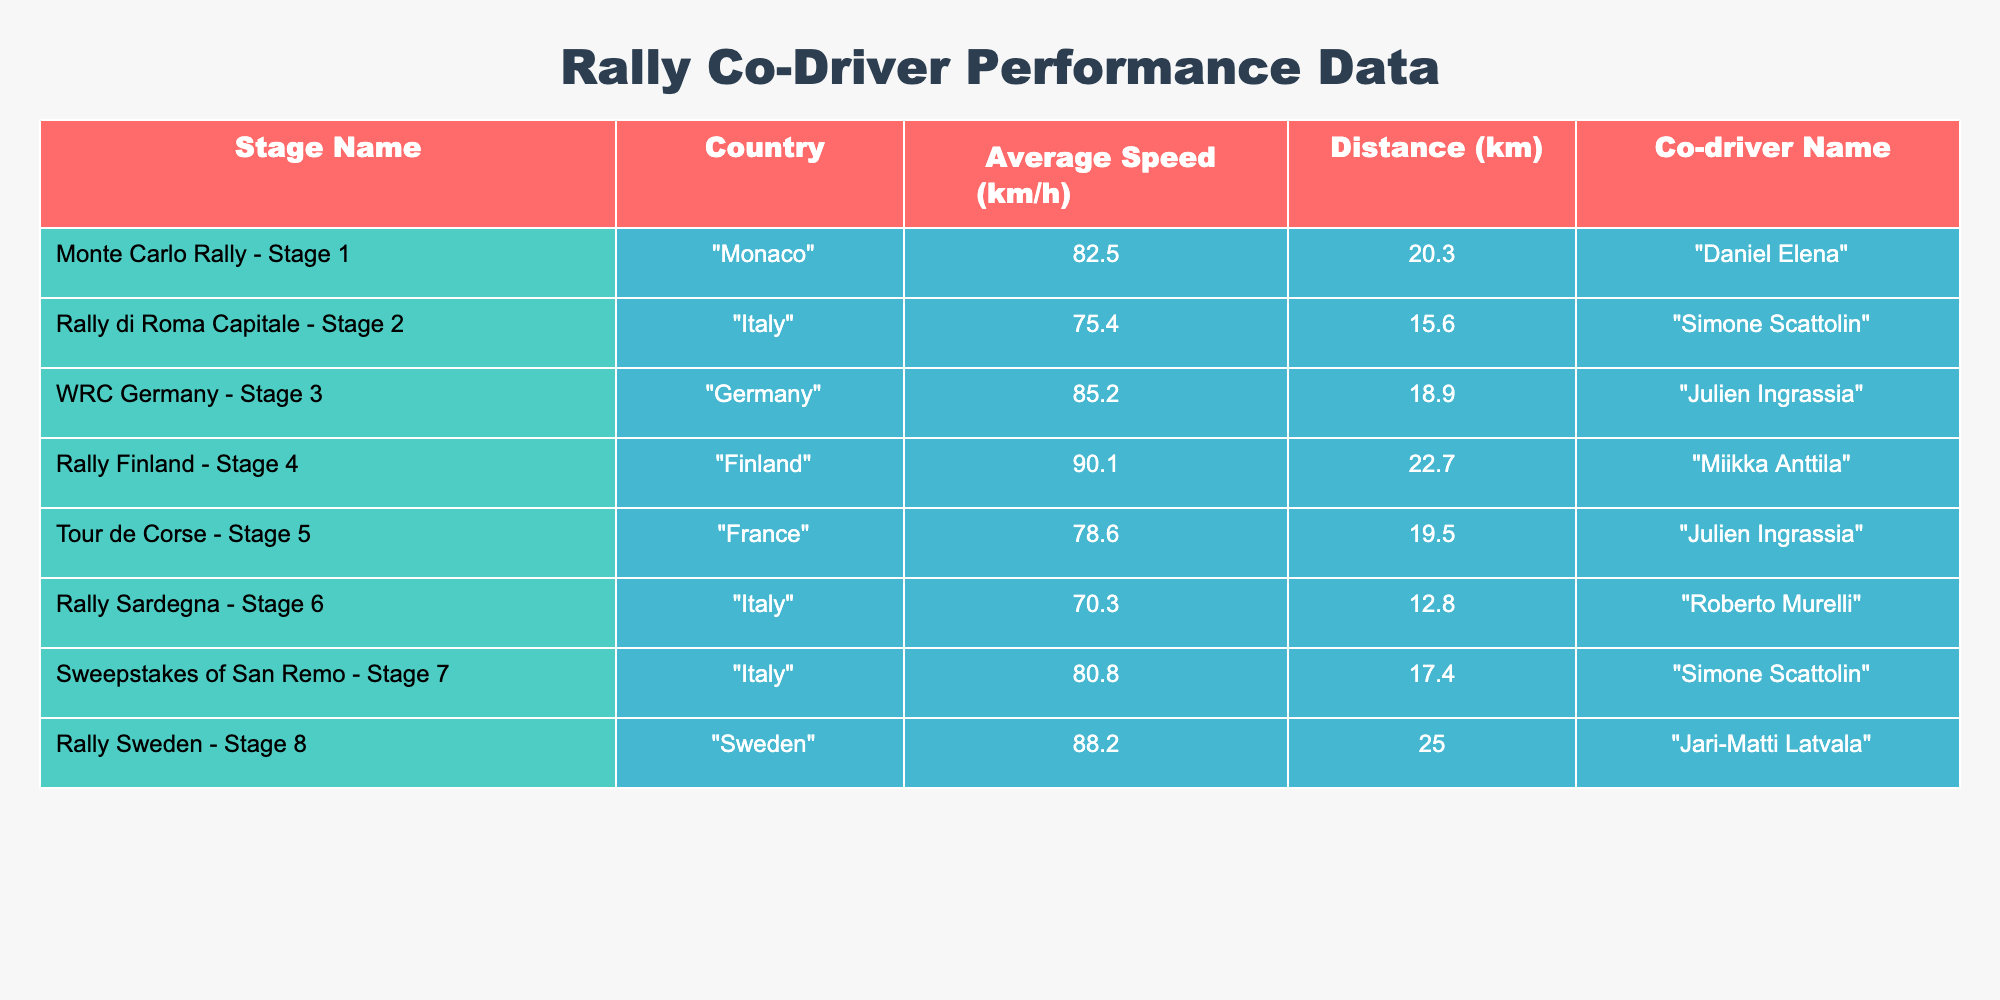What is the average speed recorded by Simone Scattolin in the rally stages? There are two stages where Simone Scattolin was a co-driver: "Rally di Roma Capitale - Stage 2" with an average speed of 75.4 km/h and "Sweepstakes of San Remo - Stage 7" with an average speed of 80.8 km/h. To find the average speed, we add these two speeds (75.4 + 80.8 = 156.2 km/h) and then divide by 2, giving us an average speed of 78.1 km/h.
Answer: 78.1 km/h Which rally stage has the highest average speed recorded? To find the highest average speed, we need to look at all the stages listed. The maximum recorded average speed is 90.1 km/h in "Rally Finland - Stage 4".
Answer: 90.1 km/h Is the average speed of "Tour de Corse - Stage 5" greater than that of "Rally Sardegna - Stage 6"? The average speed for "Tour de Corse - Stage 5" is 78.6 km/h and for "Rally Sardegna - Stage 6" it is 70.3 km/h. Since 78.6 is greater than 70.3, we can conclude that the statement is true.
Answer: Yes How many rally stages are listed for Italy, and what are their average speeds? There are three stages listed for Italy: "Rally di Roma Capitale - Stage 2" with an average speed of 75.4 km/h, "Rally Sardegna - Stage 6" with an average speed of 70.3 km/h, and "Sweepstakes of San Remo - Stage 7" with an average speed of 80.8 km/h. The average speed of these three stages is (75.4 + 70.3 + 80.8) / 3 = 75.5 km/h.
Answer: Three stages, average speed 75.5 km/h Which co-driver has the lowest average speed, and what is that speed? By inspecting the average speeds of each co-driver, we find that Roberto Murelli has the lowest average speed of 70.3 km/h in "Rally Sardegna - Stage 6".
Answer: Roberto Murelli, 70.3 km/h 